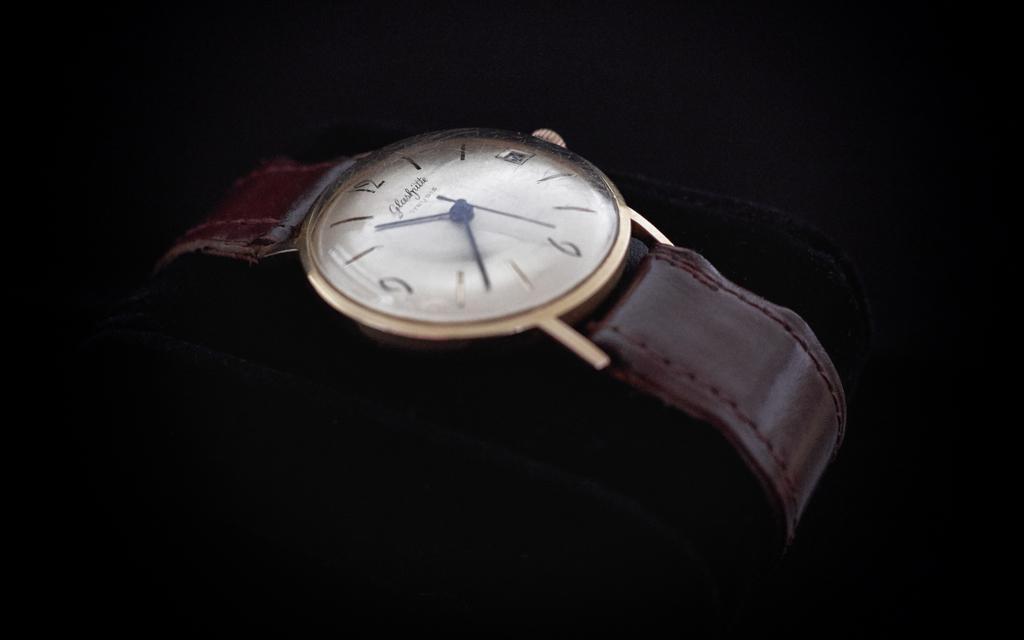Could you give a brief overview of what you see in this image? In this image I can see the watch and the background is in black color. 